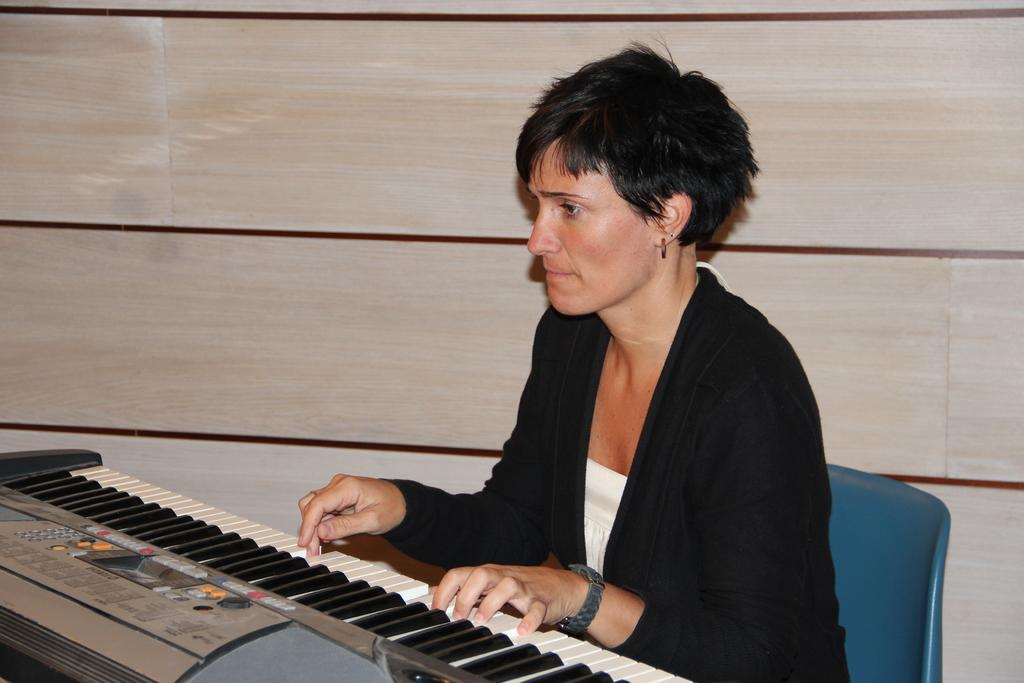Who is the main subject in the image? There is a woman in the image. What is the woman doing in the image? The woman is sitting and playing a piano. What can be seen in the background of the image? There is a wall in the background of the image. What type of bun is on the shelf in the image? There is no bun or shelf present in the image. What sound can be heard in the image due to the thunder? There is no thunder present in the image, so no such sound can be heard. 